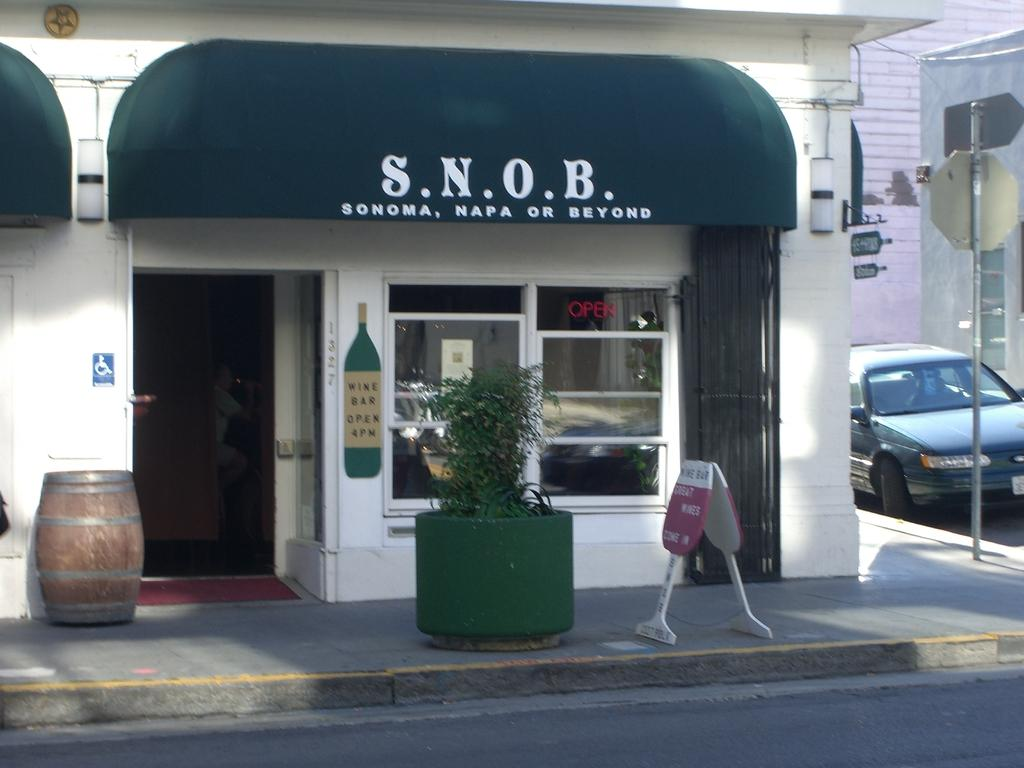What type of establishments can be seen in the image? There are stores in the image. What objects are present in the image that are typically used for displaying information or advertisements? There are boards in the image. What type of vegetation is visible in the image? There is a plant in the image. What object is commonly used for storing liquids and is present in the image? There is a barrel in the image. What type of transportation is visible in the image? There are vehicles in the image. What architectural feature is present in the image that allows for natural light and visibility? There is a window in the image. What object is present in the image that is used for supporting or anchoring other objects? There is a pole in the image. Are there any human figures present in the image? Yes, there is a person in the image. What is written on the boards in the image? Something is written on the boards in the image. Can you tell me how many babies are crawling on the floor in the image? There are no babies present in the image. What type of bun is being used to compare the sizes of the vehicles in the image? There is no bun present in the image, and no comparison of vehicle sizes is depicted. 